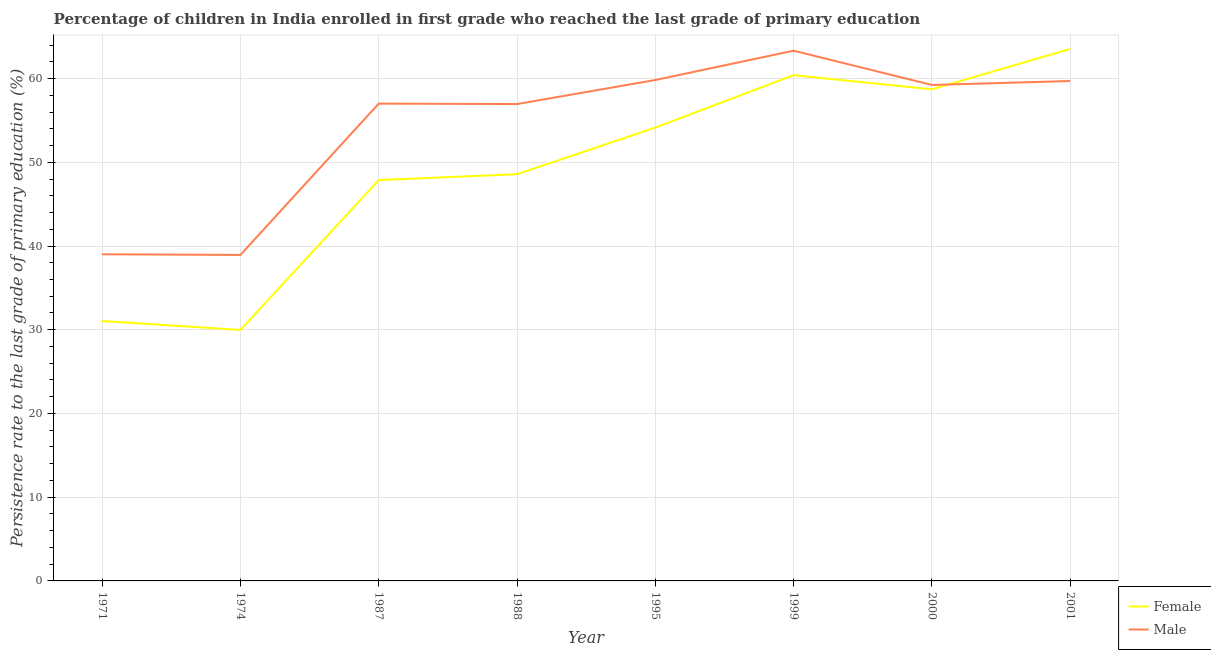Does the line corresponding to persistence rate of female students intersect with the line corresponding to persistence rate of male students?
Your answer should be compact. Yes. Is the number of lines equal to the number of legend labels?
Keep it short and to the point. Yes. What is the persistence rate of female students in 1971?
Provide a short and direct response. 31.04. Across all years, what is the maximum persistence rate of male students?
Provide a short and direct response. 63.33. Across all years, what is the minimum persistence rate of male students?
Offer a terse response. 38.93. In which year was the persistence rate of male students maximum?
Offer a very short reply. 1999. In which year was the persistence rate of male students minimum?
Make the answer very short. 1974. What is the total persistence rate of female students in the graph?
Offer a terse response. 394.25. What is the difference between the persistence rate of male students in 1971 and that in 1988?
Make the answer very short. -17.94. What is the difference between the persistence rate of female students in 1974 and the persistence rate of male students in 1971?
Make the answer very short. -9.03. What is the average persistence rate of female students per year?
Make the answer very short. 49.28. In the year 2001, what is the difference between the persistence rate of female students and persistence rate of male students?
Your answer should be compact. 3.83. What is the ratio of the persistence rate of male students in 1974 to that in 1988?
Offer a terse response. 0.68. Is the difference between the persistence rate of female students in 1999 and 2001 greater than the difference between the persistence rate of male students in 1999 and 2001?
Keep it short and to the point. No. What is the difference between the highest and the second highest persistence rate of female students?
Give a very brief answer. 3.14. What is the difference between the highest and the lowest persistence rate of female students?
Provide a succinct answer. 33.56. Is the sum of the persistence rate of female students in 1971 and 2000 greater than the maximum persistence rate of male students across all years?
Your answer should be compact. Yes. Is the persistence rate of female students strictly greater than the persistence rate of male students over the years?
Offer a very short reply. No. How many lines are there?
Provide a short and direct response. 2. How many years are there in the graph?
Make the answer very short. 8. What is the difference between two consecutive major ticks on the Y-axis?
Your response must be concise. 10. Are the values on the major ticks of Y-axis written in scientific E-notation?
Your response must be concise. No. Does the graph contain grids?
Keep it short and to the point. Yes. What is the title of the graph?
Provide a short and direct response. Percentage of children in India enrolled in first grade who reached the last grade of primary education. What is the label or title of the Y-axis?
Make the answer very short. Persistence rate to the last grade of primary education (%). What is the Persistence rate to the last grade of primary education (%) of Female in 1971?
Provide a short and direct response. 31.04. What is the Persistence rate to the last grade of primary education (%) in Male in 1971?
Provide a succinct answer. 39.01. What is the Persistence rate to the last grade of primary education (%) of Female in 1974?
Offer a terse response. 29.97. What is the Persistence rate to the last grade of primary education (%) of Male in 1974?
Keep it short and to the point. 38.93. What is the Persistence rate to the last grade of primary education (%) of Female in 1987?
Make the answer very short. 47.87. What is the Persistence rate to the last grade of primary education (%) of Male in 1987?
Keep it short and to the point. 57. What is the Persistence rate to the last grade of primary education (%) of Female in 1988?
Provide a short and direct response. 48.57. What is the Persistence rate to the last grade of primary education (%) of Male in 1988?
Your response must be concise. 56.95. What is the Persistence rate to the last grade of primary education (%) of Female in 1995?
Make the answer very short. 54.14. What is the Persistence rate to the last grade of primary education (%) in Male in 1995?
Offer a terse response. 59.82. What is the Persistence rate to the last grade of primary education (%) in Female in 1999?
Keep it short and to the point. 60.4. What is the Persistence rate to the last grade of primary education (%) in Male in 1999?
Provide a short and direct response. 63.33. What is the Persistence rate to the last grade of primary education (%) in Female in 2000?
Keep it short and to the point. 58.71. What is the Persistence rate to the last grade of primary education (%) of Male in 2000?
Provide a succinct answer. 59.23. What is the Persistence rate to the last grade of primary education (%) in Female in 2001?
Your answer should be very brief. 63.54. What is the Persistence rate to the last grade of primary education (%) in Male in 2001?
Give a very brief answer. 59.71. Across all years, what is the maximum Persistence rate to the last grade of primary education (%) of Female?
Keep it short and to the point. 63.54. Across all years, what is the maximum Persistence rate to the last grade of primary education (%) of Male?
Provide a succinct answer. 63.33. Across all years, what is the minimum Persistence rate to the last grade of primary education (%) of Female?
Your answer should be very brief. 29.97. Across all years, what is the minimum Persistence rate to the last grade of primary education (%) of Male?
Make the answer very short. 38.93. What is the total Persistence rate to the last grade of primary education (%) of Female in the graph?
Make the answer very short. 394.25. What is the total Persistence rate to the last grade of primary education (%) of Male in the graph?
Your answer should be compact. 433.99. What is the difference between the Persistence rate to the last grade of primary education (%) of Female in 1971 and that in 1974?
Your answer should be compact. 1.07. What is the difference between the Persistence rate to the last grade of primary education (%) in Male in 1971 and that in 1974?
Give a very brief answer. 0.07. What is the difference between the Persistence rate to the last grade of primary education (%) in Female in 1971 and that in 1987?
Give a very brief answer. -16.83. What is the difference between the Persistence rate to the last grade of primary education (%) in Male in 1971 and that in 1987?
Your answer should be compact. -18. What is the difference between the Persistence rate to the last grade of primary education (%) in Female in 1971 and that in 1988?
Make the answer very short. -17.53. What is the difference between the Persistence rate to the last grade of primary education (%) of Male in 1971 and that in 1988?
Keep it short and to the point. -17.94. What is the difference between the Persistence rate to the last grade of primary education (%) of Female in 1971 and that in 1995?
Provide a succinct answer. -23.1. What is the difference between the Persistence rate to the last grade of primary education (%) of Male in 1971 and that in 1995?
Give a very brief answer. -20.81. What is the difference between the Persistence rate to the last grade of primary education (%) of Female in 1971 and that in 1999?
Offer a very short reply. -29.36. What is the difference between the Persistence rate to the last grade of primary education (%) of Male in 1971 and that in 1999?
Your response must be concise. -24.32. What is the difference between the Persistence rate to the last grade of primary education (%) in Female in 1971 and that in 2000?
Keep it short and to the point. -27.67. What is the difference between the Persistence rate to the last grade of primary education (%) in Male in 1971 and that in 2000?
Offer a very short reply. -20.22. What is the difference between the Persistence rate to the last grade of primary education (%) in Female in 1971 and that in 2001?
Ensure brevity in your answer.  -32.5. What is the difference between the Persistence rate to the last grade of primary education (%) of Male in 1971 and that in 2001?
Provide a succinct answer. -20.7. What is the difference between the Persistence rate to the last grade of primary education (%) in Female in 1974 and that in 1987?
Give a very brief answer. -17.9. What is the difference between the Persistence rate to the last grade of primary education (%) of Male in 1974 and that in 1987?
Your answer should be compact. -18.07. What is the difference between the Persistence rate to the last grade of primary education (%) in Female in 1974 and that in 1988?
Provide a succinct answer. -18.6. What is the difference between the Persistence rate to the last grade of primary education (%) of Male in 1974 and that in 1988?
Your answer should be compact. -18.02. What is the difference between the Persistence rate to the last grade of primary education (%) of Female in 1974 and that in 1995?
Ensure brevity in your answer.  -24.17. What is the difference between the Persistence rate to the last grade of primary education (%) in Male in 1974 and that in 1995?
Offer a terse response. -20.89. What is the difference between the Persistence rate to the last grade of primary education (%) in Female in 1974 and that in 1999?
Keep it short and to the point. -30.43. What is the difference between the Persistence rate to the last grade of primary education (%) of Male in 1974 and that in 1999?
Provide a short and direct response. -24.39. What is the difference between the Persistence rate to the last grade of primary education (%) in Female in 1974 and that in 2000?
Ensure brevity in your answer.  -28.74. What is the difference between the Persistence rate to the last grade of primary education (%) of Male in 1974 and that in 2000?
Keep it short and to the point. -20.3. What is the difference between the Persistence rate to the last grade of primary education (%) of Female in 1974 and that in 2001?
Provide a succinct answer. -33.56. What is the difference between the Persistence rate to the last grade of primary education (%) of Male in 1974 and that in 2001?
Ensure brevity in your answer.  -20.77. What is the difference between the Persistence rate to the last grade of primary education (%) of Female in 1987 and that in 1988?
Offer a terse response. -0.7. What is the difference between the Persistence rate to the last grade of primary education (%) of Male in 1987 and that in 1988?
Provide a succinct answer. 0.05. What is the difference between the Persistence rate to the last grade of primary education (%) in Female in 1987 and that in 1995?
Your response must be concise. -6.27. What is the difference between the Persistence rate to the last grade of primary education (%) of Male in 1987 and that in 1995?
Make the answer very short. -2.82. What is the difference between the Persistence rate to the last grade of primary education (%) in Female in 1987 and that in 1999?
Your answer should be very brief. -12.53. What is the difference between the Persistence rate to the last grade of primary education (%) of Male in 1987 and that in 1999?
Offer a very short reply. -6.32. What is the difference between the Persistence rate to the last grade of primary education (%) of Female in 1987 and that in 2000?
Offer a terse response. -10.84. What is the difference between the Persistence rate to the last grade of primary education (%) of Male in 1987 and that in 2000?
Make the answer very short. -2.23. What is the difference between the Persistence rate to the last grade of primary education (%) of Female in 1987 and that in 2001?
Make the answer very short. -15.67. What is the difference between the Persistence rate to the last grade of primary education (%) in Male in 1987 and that in 2001?
Ensure brevity in your answer.  -2.7. What is the difference between the Persistence rate to the last grade of primary education (%) of Female in 1988 and that in 1995?
Make the answer very short. -5.57. What is the difference between the Persistence rate to the last grade of primary education (%) in Male in 1988 and that in 1995?
Provide a succinct answer. -2.87. What is the difference between the Persistence rate to the last grade of primary education (%) in Female in 1988 and that in 1999?
Your answer should be very brief. -11.83. What is the difference between the Persistence rate to the last grade of primary education (%) of Male in 1988 and that in 1999?
Your response must be concise. -6.37. What is the difference between the Persistence rate to the last grade of primary education (%) of Female in 1988 and that in 2000?
Offer a terse response. -10.14. What is the difference between the Persistence rate to the last grade of primary education (%) in Male in 1988 and that in 2000?
Provide a short and direct response. -2.28. What is the difference between the Persistence rate to the last grade of primary education (%) of Female in 1988 and that in 2001?
Provide a succinct answer. -14.96. What is the difference between the Persistence rate to the last grade of primary education (%) in Male in 1988 and that in 2001?
Make the answer very short. -2.75. What is the difference between the Persistence rate to the last grade of primary education (%) in Female in 1995 and that in 1999?
Ensure brevity in your answer.  -6.26. What is the difference between the Persistence rate to the last grade of primary education (%) of Male in 1995 and that in 1999?
Provide a succinct answer. -3.5. What is the difference between the Persistence rate to the last grade of primary education (%) in Female in 1995 and that in 2000?
Your answer should be very brief. -4.57. What is the difference between the Persistence rate to the last grade of primary education (%) of Male in 1995 and that in 2000?
Make the answer very short. 0.59. What is the difference between the Persistence rate to the last grade of primary education (%) in Female in 1995 and that in 2001?
Offer a terse response. -9.4. What is the difference between the Persistence rate to the last grade of primary education (%) in Male in 1995 and that in 2001?
Provide a short and direct response. 0.12. What is the difference between the Persistence rate to the last grade of primary education (%) in Female in 1999 and that in 2000?
Provide a succinct answer. 1.69. What is the difference between the Persistence rate to the last grade of primary education (%) in Male in 1999 and that in 2000?
Your response must be concise. 4.09. What is the difference between the Persistence rate to the last grade of primary education (%) of Female in 1999 and that in 2001?
Keep it short and to the point. -3.14. What is the difference between the Persistence rate to the last grade of primary education (%) in Male in 1999 and that in 2001?
Ensure brevity in your answer.  3.62. What is the difference between the Persistence rate to the last grade of primary education (%) in Female in 2000 and that in 2001?
Your response must be concise. -4.82. What is the difference between the Persistence rate to the last grade of primary education (%) of Male in 2000 and that in 2001?
Your answer should be very brief. -0.47. What is the difference between the Persistence rate to the last grade of primary education (%) in Female in 1971 and the Persistence rate to the last grade of primary education (%) in Male in 1974?
Provide a succinct answer. -7.89. What is the difference between the Persistence rate to the last grade of primary education (%) in Female in 1971 and the Persistence rate to the last grade of primary education (%) in Male in 1987?
Your response must be concise. -25.96. What is the difference between the Persistence rate to the last grade of primary education (%) in Female in 1971 and the Persistence rate to the last grade of primary education (%) in Male in 1988?
Your response must be concise. -25.91. What is the difference between the Persistence rate to the last grade of primary education (%) in Female in 1971 and the Persistence rate to the last grade of primary education (%) in Male in 1995?
Your response must be concise. -28.78. What is the difference between the Persistence rate to the last grade of primary education (%) of Female in 1971 and the Persistence rate to the last grade of primary education (%) of Male in 1999?
Ensure brevity in your answer.  -32.29. What is the difference between the Persistence rate to the last grade of primary education (%) of Female in 1971 and the Persistence rate to the last grade of primary education (%) of Male in 2000?
Make the answer very short. -28.19. What is the difference between the Persistence rate to the last grade of primary education (%) of Female in 1971 and the Persistence rate to the last grade of primary education (%) of Male in 2001?
Give a very brief answer. -28.66. What is the difference between the Persistence rate to the last grade of primary education (%) of Female in 1974 and the Persistence rate to the last grade of primary education (%) of Male in 1987?
Your answer should be compact. -27.03. What is the difference between the Persistence rate to the last grade of primary education (%) of Female in 1974 and the Persistence rate to the last grade of primary education (%) of Male in 1988?
Ensure brevity in your answer.  -26.98. What is the difference between the Persistence rate to the last grade of primary education (%) in Female in 1974 and the Persistence rate to the last grade of primary education (%) in Male in 1995?
Your response must be concise. -29.85. What is the difference between the Persistence rate to the last grade of primary education (%) of Female in 1974 and the Persistence rate to the last grade of primary education (%) of Male in 1999?
Provide a short and direct response. -33.35. What is the difference between the Persistence rate to the last grade of primary education (%) of Female in 1974 and the Persistence rate to the last grade of primary education (%) of Male in 2000?
Ensure brevity in your answer.  -29.26. What is the difference between the Persistence rate to the last grade of primary education (%) of Female in 1974 and the Persistence rate to the last grade of primary education (%) of Male in 2001?
Your response must be concise. -29.73. What is the difference between the Persistence rate to the last grade of primary education (%) of Female in 1987 and the Persistence rate to the last grade of primary education (%) of Male in 1988?
Give a very brief answer. -9.08. What is the difference between the Persistence rate to the last grade of primary education (%) in Female in 1987 and the Persistence rate to the last grade of primary education (%) in Male in 1995?
Give a very brief answer. -11.95. What is the difference between the Persistence rate to the last grade of primary education (%) in Female in 1987 and the Persistence rate to the last grade of primary education (%) in Male in 1999?
Offer a very short reply. -15.46. What is the difference between the Persistence rate to the last grade of primary education (%) of Female in 1987 and the Persistence rate to the last grade of primary education (%) of Male in 2000?
Keep it short and to the point. -11.36. What is the difference between the Persistence rate to the last grade of primary education (%) of Female in 1987 and the Persistence rate to the last grade of primary education (%) of Male in 2001?
Ensure brevity in your answer.  -11.83. What is the difference between the Persistence rate to the last grade of primary education (%) of Female in 1988 and the Persistence rate to the last grade of primary education (%) of Male in 1995?
Your answer should be compact. -11.25. What is the difference between the Persistence rate to the last grade of primary education (%) of Female in 1988 and the Persistence rate to the last grade of primary education (%) of Male in 1999?
Make the answer very short. -14.75. What is the difference between the Persistence rate to the last grade of primary education (%) in Female in 1988 and the Persistence rate to the last grade of primary education (%) in Male in 2000?
Your response must be concise. -10.66. What is the difference between the Persistence rate to the last grade of primary education (%) in Female in 1988 and the Persistence rate to the last grade of primary education (%) in Male in 2001?
Offer a terse response. -11.13. What is the difference between the Persistence rate to the last grade of primary education (%) of Female in 1995 and the Persistence rate to the last grade of primary education (%) of Male in 1999?
Give a very brief answer. -9.19. What is the difference between the Persistence rate to the last grade of primary education (%) in Female in 1995 and the Persistence rate to the last grade of primary education (%) in Male in 2000?
Give a very brief answer. -5.09. What is the difference between the Persistence rate to the last grade of primary education (%) of Female in 1995 and the Persistence rate to the last grade of primary education (%) of Male in 2001?
Offer a terse response. -5.57. What is the difference between the Persistence rate to the last grade of primary education (%) in Female in 1999 and the Persistence rate to the last grade of primary education (%) in Male in 2000?
Your answer should be compact. 1.17. What is the difference between the Persistence rate to the last grade of primary education (%) in Female in 1999 and the Persistence rate to the last grade of primary education (%) in Male in 2001?
Offer a very short reply. 0.7. What is the difference between the Persistence rate to the last grade of primary education (%) of Female in 2000 and the Persistence rate to the last grade of primary education (%) of Male in 2001?
Your answer should be compact. -0.99. What is the average Persistence rate to the last grade of primary education (%) of Female per year?
Provide a short and direct response. 49.28. What is the average Persistence rate to the last grade of primary education (%) in Male per year?
Provide a short and direct response. 54.25. In the year 1971, what is the difference between the Persistence rate to the last grade of primary education (%) of Female and Persistence rate to the last grade of primary education (%) of Male?
Give a very brief answer. -7.97. In the year 1974, what is the difference between the Persistence rate to the last grade of primary education (%) of Female and Persistence rate to the last grade of primary education (%) of Male?
Your answer should be compact. -8.96. In the year 1987, what is the difference between the Persistence rate to the last grade of primary education (%) of Female and Persistence rate to the last grade of primary education (%) of Male?
Keep it short and to the point. -9.13. In the year 1988, what is the difference between the Persistence rate to the last grade of primary education (%) in Female and Persistence rate to the last grade of primary education (%) in Male?
Your answer should be very brief. -8.38. In the year 1995, what is the difference between the Persistence rate to the last grade of primary education (%) in Female and Persistence rate to the last grade of primary education (%) in Male?
Make the answer very short. -5.68. In the year 1999, what is the difference between the Persistence rate to the last grade of primary education (%) of Female and Persistence rate to the last grade of primary education (%) of Male?
Provide a succinct answer. -2.92. In the year 2000, what is the difference between the Persistence rate to the last grade of primary education (%) in Female and Persistence rate to the last grade of primary education (%) in Male?
Provide a short and direct response. -0.52. In the year 2001, what is the difference between the Persistence rate to the last grade of primary education (%) in Female and Persistence rate to the last grade of primary education (%) in Male?
Your answer should be compact. 3.83. What is the ratio of the Persistence rate to the last grade of primary education (%) in Female in 1971 to that in 1974?
Provide a succinct answer. 1.04. What is the ratio of the Persistence rate to the last grade of primary education (%) of Male in 1971 to that in 1974?
Ensure brevity in your answer.  1. What is the ratio of the Persistence rate to the last grade of primary education (%) of Female in 1971 to that in 1987?
Your answer should be very brief. 0.65. What is the ratio of the Persistence rate to the last grade of primary education (%) of Male in 1971 to that in 1987?
Your answer should be very brief. 0.68. What is the ratio of the Persistence rate to the last grade of primary education (%) of Female in 1971 to that in 1988?
Offer a terse response. 0.64. What is the ratio of the Persistence rate to the last grade of primary education (%) in Male in 1971 to that in 1988?
Keep it short and to the point. 0.68. What is the ratio of the Persistence rate to the last grade of primary education (%) of Female in 1971 to that in 1995?
Provide a short and direct response. 0.57. What is the ratio of the Persistence rate to the last grade of primary education (%) of Male in 1971 to that in 1995?
Make the answer very short. 0.65. What is the ratio of the Persistence rate to the last grade of primary education (%) in Female in 1971 to that in 1999?
Keep it short and to the point. 0.51. What is the ratio of the Persistence rate to the last grade of primary education (%) of Male in 1971 to that in 1999?
Your answer should be very brief. 0.62. What is the ratio of the Persistence rate to the last grade of primary education (%) of Female in 1971 to that in 2000?
Offer a terse response. 0.53. What is the ratio of the Persistence rate to the last grade of primary education (%) of Male in 1971 to that in 2000?
Your answer should be compact. 0.66. What is the ratio of the Persistence rate to the last grade of primary education (%) in Female in 1971 to that in 2001?
Provide a short and direct response. 0.49. What is the ratio of the Persistence rate to the last grade of primary education (%) in Male in 1971 to that in 2001?
Keep it short and to the point. 0.65. What is the ratio of the Persistence rate to the last grade of primary education (%) in Female in 1974 to that in 1987?
Make the answer very short. 0.63. What is the ratio of the Persistence rate to the last grade of primary education (%) of Male in 1974 to that in 1987?
Provide a short and direct response. 0.68. What is the ratio of the Persistence rate to the last grade of primary education (%) in Female in 1974 to that in 1988?
Provide a succinct answer. 0.62. What is the ratio of the Persistence rate to the last grade of primary education (%) in Male in 1974 to that in 1988?
Your answer should be very brief. 0.68. What is the ratio of the Persistence rate to the last grade of primary education (%) in Female in 1974 to that in 1995?
Provide a short and direct response. 0.55. What is the ratio of the Persistence rate to the last grade of primary education (%) in Male in 1974 to that in 1995?
Provide a succinct answer. 0.65. What is the ratio of the Persistence rate to the last grade of primary education (%) of Female in 1974 to that in 1999?
Your response must be concise. 0.5. What is the ratio of the Persistence rate to the last grade of primary education (%) of Male in 1974 to that in 1999?
Make the answer very short. 0.61. What is the ratio of the Persistence rate to the last grade of primary education (%) in Female in 1974 to that in 2000?
Offer a terse response. 0.51. What is the ratio of the Persistence rate to the last grade of primary education (%) in Male in 1974 to that in 2000?
Provide a short and direct response. 0.66. What is the ratio of the Persistence rate to the last grade of primary education (%) of Female in 1974 to that in 2001?
Ensure brevity in your answer.  0.47. What is the ratio of the Persistence rate to the last grade of primary education (%) in Male in 1974 to that in 2001?
Give a very brief answer. 0.65. What is the ratio of the Persistence rate to the last grade of primary education (%) in Female in 1987 to that in 1988?
Offer a very short reply. 0.99. What is the ratio of the Persistence rate to the last grade of primary education (%) in Male in 1987 to that in 1988?
Your answer should be compact. 1. What is the ratio of the Persistence rate to the last grade of primary education (%) of Female in 1987 to that in 1995?
Provide a succinct answer. 0.88. What is the ratio of the Persistence rate to the last grade of primary education (%) in Male in 1987 to that in 1995?
Your response must be concise. 0.95. What is the ratio of the Persistence rate to the last grade of primary education (%) of Female in 1987 to that in 1999?
Keep it short and to the point. 0.79. What is the ratio of the Persistence rate to the last grade of primary education (%) of Male in 1987 to that in 1999?
Provide a short and direct response. 0.9. What is the ratio of the Persistence rate to the last grade of primary education (%) in Female in 1987 to that in 2000?
Offer a very short reply. 0.82. What is the ratio of the Persistence rate to the last grade of primary education (%) in Male in 1987 to that in 2000?
Keep it short and to the point. 0.96. What is the ratio of the Persistence rate to the last grade of primary education (%) of Female in 1987 to that in 2001?
Your answer should be very brief. 0.75. What is the ratio of the Persistence rate to the last grade of primary education (%) in Male in 1987 to that in 2001?
Your answer should be very brief. 0.95. What is the ratio of the Persistence rate to the last grade of primary education (%) of Female in 1988 to that in 1995?
Give a very brief answer. 0.9. What is the ratio of the Persistence rate to the last grade of primary education (%) in Male in 1988 to that in 1995?
Offer a terse response. 0.95. What is the ratio of the Persistence rate to the last grade of primary education (%) in Female in 1988 to that in 1999?
Give a very brief answer. 0.8. What is the ratio of the Persistence rate to the last grade of primary education (%) of Male in 1988 to that in 1999?
Make the answer very short. 0.9. What is the ratio of the Persistence rate to the last grade of primary education (%) in Female in 1988 to that in 2000?
Offer a terse response. 0.83. What is the ratio of the Persistence rate to the last grade of primary education (%) in Male in 1988 to that in 2000?
Offer a terse response. 0.96. What is the ratio of the Persistence rate to the last grade of primary education (%) of Female in 1988 to that in 2001?
Offer a very short reply. 0.76. What is the ratio of the Persistence rate to the last grade of primary education (%) in Male in 1988 to that in 2001?
Provide a succinct answer. 0.95. What is the ratio of the Persistence rate to the last grade of primary education (%) in Female in 1995 to that in 1999?
Your answer should be compact. 0.9. What is the ratio of the Persistence rate to the last grade of primary education (%) in Male in 1995 to that in 1999?
Your answer should be compact. 0.94. What is the ratio of the Persistence rate to the last grade of primary education (%) of Female in 1995 to that in 2000?
Your response must be concise. 0.92. What is the ratio of the Persistence rate to the last grade of primary education (%) of Male in 1995 to that in 2000?
Give a very brief answer. 1.01. What is the ratio of the Persistence rate to the last grade of primary education (%) in Female in 1995 to that in 2001?
Your answer should be very brief. 0.85. What is the ratio of the Persistence rate to the last grade of primary education (%) in Male in 1995 to that in 2001?
Ensure brevity in your answer.  1. What is the ratio of the Persistence rate to the last grade of primary education (%) in Female in 1999 to that in 2000?
Provide a short and direct response. 1.03. What is the ratio of the Persistence rate to the last grade of primary education (%) of Male in 1999 to that in 2000?
Give a very brief answer. 1.07. What is the ratio of the Persistence rate to the last grade of primary education (%) in Female in 1999 to that in 2001?
Offer a terse response. 0.95. What is the ratio of the Persistence rate to the last grade of primary education (%) in Male in 1999 to that in 2001?
Offer a very short reply. 1.06. What is the ratio of the Persistence rate to the last grade of primary education (%) of Female in 2000 to that in 2001?
Ensure brevity in your answer.  0.92. What is the ratio of the Persistence rate to the last grade of primary education (%) of Male in 2000 to that in 2001?
Offer a very short reply. 0.99. What is the difference between the highest and the second highest Persistence rate to the last grade of primary education (%) in Female?
Your answer should be very brief. 3.14. What is the difference between the highest and the second highest Persistence rate to the last grade of primary education (%) of Male?
Offer a very short reply. 3.5. What is the difference between the highest and the lowest Persistence rate to the last grade of primary education (%) of Female?
Your response must be concise. 33.56. What is the difference between the highest and the lowest Persistence rate to the last grade of primary education (%) in Male?
Ensure brevity in your answer.  24.39. 